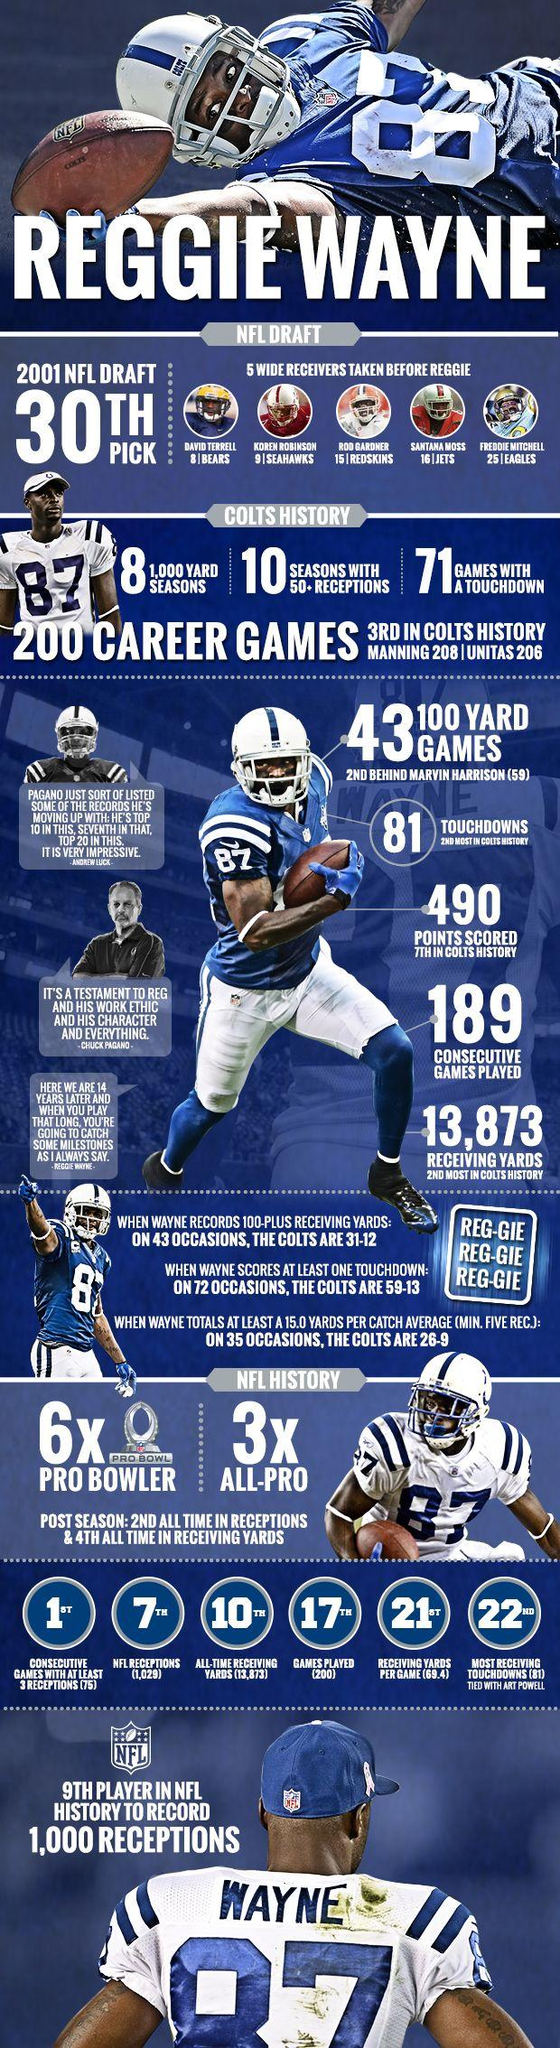Highlight a few significant elements in this photo. Reggie Wayne was elected to the All-Pro team three times. Santana Moss belongs to the Jets team. 